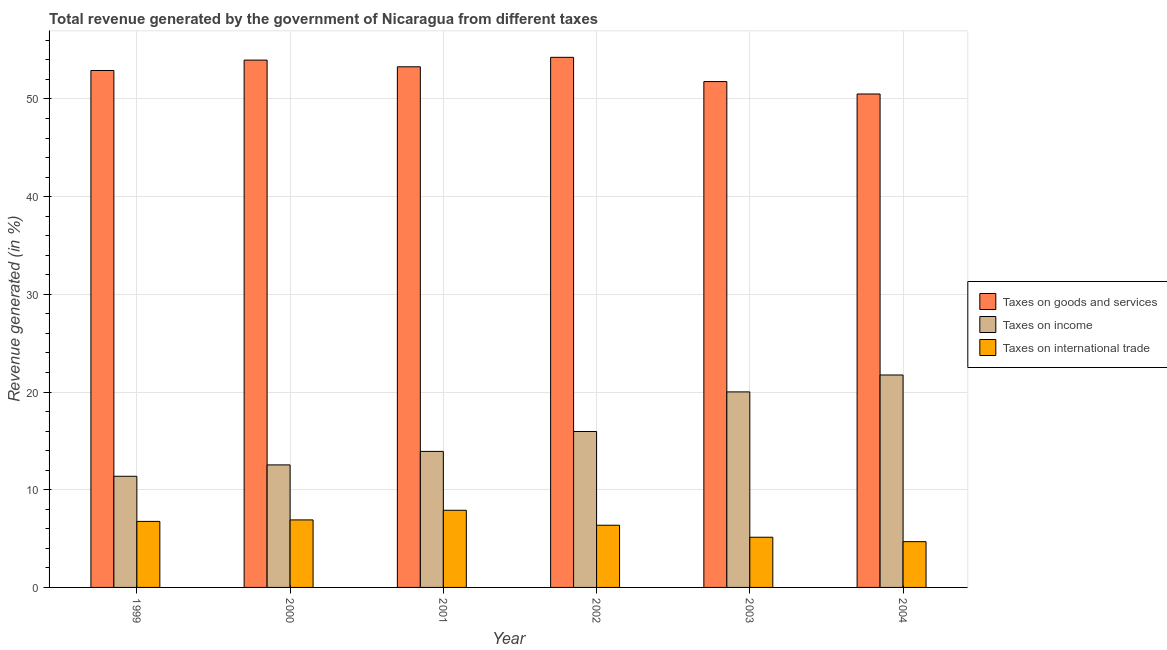How many different coloured bars are there?
Offer a terse response. 3. How many bars are there on the 5th tick from the right?
Make the answer very short. 3. What is the percentage of revenue generated by taxes on income in 2004?
Provide a short and direct response. 21.75. Across all years, what is the maximum percentage of revenue generated by taxes on income?
Give a very brief answer. 21.75. Across all years, what is the minimum percentage of revenue generated by taxes on income?
Offer a very short reply. 11.38. What is the total percentage of revenue generated by taxes on goods and services in the graph?
Ensure brevity in your answer.  316.75. What is the difference between the percentage of revenue generated by taxes on goods and services in 2000 and that in 2002?
Your response must be concise. -0.28. What is the difference between the percentage of revenue generated by taxes on goods and services in 1999 and the percentage of revenue generated by tax on international trade in 2000?
Keep it short and to the point. -1.06. What is the average percentage of revenue generated by tax on international trade per year?
Keep it short and to the point. 6.29. In how many years, is the percentage of revenue generated by taxes on goods and services greater than 16 %?
Keep it short and to the point. 6. What is the ratio of the percentage of revenue generated by taxes on goods and services in 1999 to that in 2002?
Your answer should be very brief. 0.98. What is the difference between the highest and the second highest percentage of revenue generated by taxes on goods and services?
Ensure brevity in your answer.  0.28. What is the difference between the highest and the lowest percentage of revenue generated by taxes on goods and services?
Offer a very short reply. 3.75. What does the 3rd bar from the left in 1999 represents?
Give a very brief answer. Taxes on international trade. What does the 1st bar from the right in 2001 represents?
Your answer should be compact. Taxes on international trade. How many bars are there?
Give a very brief answer. 18. How many years are there in the graph?
Give a very brief answer. 6. Are the values on the major ticks of Y-axis written in scientific E-notation?
Offer a very short reply. No. Where does the legend appear in the graph?
Provide a succinct answer. Center right. What is the title of the graph?
Provide a succinct answer. Total revenue generated by the government of Nicaragua from different taxes. Does "Financial account" appear as one of the legend labels in the graph?
Provide a succinct answer. No. What is the label or title of the X-axis?
Keep it short and to the point. Year. What is the label or title of the Y-axis?
Make the answer very short. Revenue generated (in %). What is the Revenue generated (in %) of Taxes on goods and services in 1999?
Your answer should be compact. 52.92. What is the Revenue generated (in %) of Taxes on income in 1999?
Offer a very short reply. 11.38. What is the Revenue generated (in %) in Taxes on international trade in 1999?
Keep it short and to the point. 6.76. What is the Revenue generated (in %) of Taxes on goods and services in 2000?
Ensure brevity in your answer.  53.98. What is the Revenue generated (in %) in Taxes on income in 2000?
Your answer should be compact. 12.54. What is the Revenue generated (in %) of Taxes on international trade in 2000?
Keep it short and to the point. 6.91. What is the Revenue generated (in %) in Taxes on goods and services in 2001?
Offer a terse response. 53.3. What is the Revenue generated (in %) of Taxes on income in 2001?
Keep it short and to the point. 13.93. What is the Revenue generated (in %) of Taxes on international trade in 2001?
Your answer should be very brief. 7.9. What is the Revenue generated (in %) of Taxes on goods and services in 2002?
Offer a very short reply. 54.26. What is the Revenue generated (in %) in Taxes on income in 2002?
Your answer should be very brief. 15.96. What is the Revenue generated (in %) in Taxes on international trade in 2002?
Provide a short and direct response. 6.36. What is the Revenue generated (in %) of Taxes on goods and services in 2003?
Give a very brief answer. 51.78. What is the Revenue generated (in %) in Taxes on income in 2003?
Give a very brief answer. 20.02. What is the Revenue generated (in %) in Taxes on international trade in 2003?
Your answer should be compact. 5.14. What is the Revenue generated (in %) of Taxes on goods and services in 2004?
Your answer should be compact. 50.51. What is the Revenue generated (in %) of Taxes on income in 2004?
Offer a terse response. 21.75. What is the Revenue generated (in %) in Taxes on international trade in 2004?
Keep it short and to the point. 4.69. Across all years, what is the maximum Revenue generated (in %) of Taxes on goods and services?
Give a very brief answer. 54.26. Across all years, what is the maximum Revenue generated (in %) in Taxes on income?
Offer a terse response. 21.75. Across all years, what is the maximum Revenue generated (in %) of Taxes on international trade?
Provide a succinct answer. 7.9. Across all years, what is the minimum Revenue generated (in %) of Taxes on goods and services?
Ensure brevity in your answer.  50.51. Across all years, what is the minimum Revenue generated (in %) in Taxes on income?
Give a very brief answer. 11.38. Across all years, what is the minimum Revenue generated (in %) of Taxes on international trade?
Ensure brevity in your answer.  4.69. What is the total Revenue generated (in %) in Taxes on goods and services in the graph?
Ensure brevity in your answer.  316.75. What is the total Revenue generated (in %) of Taxes on income in the graph?
Your answer should be very brief. 95.57. What is the total Revenue generated (in %) in Taxes on international trade in the graph?
Your response must be concise. 37.76. What is the difference between the Revenue generated (in %) of Taxes on goods and services in 1999 and that in 2000?
Provide a short and direct response. -1.06. What is the difference between the Revenue generated (in %) in Taxes on income in 1999 and that in 2000?
Your response must be concise. -1.16. What is the difference between the Revenue generated (in %) in Taxes on international trade in 1999 and that in 2000?
Your answer should be very brief. -0.15. What is the difference between the Revenue generated (in %) in Taxes on goods and services in 1999 and that in 2001?
Provide a succinct answer. -0.38. What is the difference between the Revenue generated (in %) of Taxes on income in 1999 and that in 2001?
Offer a terse response. -2.55. What is the difference between the Revenue generated (in %) in Taxes on international trade in 1999 and that in 2001?
Your answer should be very brief. -1.14. What is the difference between the Revenue generated (in %) of Taxes on goods and services in 1999 and that in 2002?
Keep it short and to the point. -1.35. What is the difference between the Revenue generated (in %) of Taxes on income in 1999 and that in 2002?
Give a very brief answer. -4.58. What is the difference between the Revenue generated (in %) in Taxes on international trade in 1999 and that in 2002?
Your answer should be compact. 0.39. What is the difference between the Revenue generated (in %) in Taxes on goods and services in 1999 and that in 2003?
Your answer should be compact. 1.13. What is the difference between the Revenue generated (in %) in Taxes on income in 1999 and that in 2003?
Offer a terse response. -8.64. What is the difference between the Revenue generated (in %) of Taxes on international trade in 1999 and that in 2003?
Keep it short and to the point. 1.62. What is the difference between the Revenue generated (in %) in Taxes on goods and services in 1999 and that in 2004?
Your answer should be very brief. 2.41. What is the difference between the Revenue generated (in %) of Taxes on income in 1999 and that in 2004?
Your answer should be compact. -10.37. What is the difference between the Revenue generated (in %) of Taxes on international trade in 1999 and that in 2004?
Keep it short and to the point. 2.07. What is the difference between the Revenue generated (in %) of Taxes on goods and services in 2000 and that in 2001?
Provide a succinct answer. 0.68. What is the difference between the Revenue generated (in %) in Taxes on income in 2000 and that in 2001?
Your answer should be compact. -1.38. What is the difference between the Revenue generated (in %) of Taxes on international trade in 2000 and that in 2001?
Ensure brevity in your answer.  -0.99. What is the difference between the Revenue generated (in %) in Taxes on goods and services in 2000 and that in 2002?
Offer a terse response. -0.28. What is the difference between the Revenue generated (in %) of Taxes on income in 2000 and that in 2002?
Your response must be concise. -3.42. What is the difference between the Revenue generated (in %) in Taxes on international trade in 2000 and that in 2002?
Your answer should be very brief. 0.55. What is the difference between the Revenue generated (in %) in Taxes on goods and services in 2000 and that in 2003?
Your answer should be compact. 2.2. What is the difference between the Revenue generated (in %) of Taxes on income in 2000 and that in 2003?
Ensure brevity in your answer.  -7.47. What is the difference between the Revenue generated (in %) in Taxes on international trade in 2000 and that in 2003?
Your response must be concise. 1.78. What is the difference between the Revenue generated (in %) in Taxes on goods and services in 2000 and that in 2004?
Give a very brief answer. 3.47. What is the difference between the Revenue generated (in %) in Taxes on income in 2000 and that in 2004?
Make the answer very short. -9.2. What is the difference between the Revenue generated (in %) in Taxes on international trade in 2000 and that in 2004?
Your answer should be very brief. 2.23. What is the difference between the Revenue generated (in %) of Taxes on goods and services in 2001 and that in 2002?
Your answer should be compact. -0.97. What is the difference between the Revenue generated (in %) in Taxes on income in 2001 and that in 2002?
Offer a very short reply. -2.04. What is the difference between the Revenue generated (in %) in Taxes on international trade in 2001 and that in 2002?
Your answer should be compact. 1.53. What is the difference between the Revenue generated (in %) in Taxes on goods and services in 2001 and that in 2003?
Your answer should be very brief. 1.51. What is the difference between the Revenue generated (in %) in Taxes on income in 2001 and that in 2003?
Provide a succinct answer. -6.09. What is the difference between the Revenue generated (in %) of Taxes on international trade in 2001 and that in 2003?
Make the answer very short. 2.76. What is the difference between the Revenue generated (in %) of Taxes on goods and services in 2001 and that in 2004?
Ensure brevity in your answer.  2.79. What is the difference between the Revenue generated (in %) of Taxes on income in 2001 and that in 2004?
Ensure brevity in your answer.  -7.82. What is the difference between the Revenue generated (in %) of Taxes on international trade in 2001 and that in 2004?
Ensure brevity in your answer.  3.21. What is the difference between the Revenue generated (in %) in Taxes on goods and services in 2002 and that in 2003?
Make the answer very short. 2.48. What is the difference between the Revenue generated (in %) of Taxes on income in 2002 and that in 2003?
Ensure brevity in your answer.  -4.05. What is the difference between the Revenue generated (in %) of Taxes on international trade in 2002 and that in 2003?
Give a very brief answer. 1.23. What is the difference between the Revenue generated (in %) of Taxes on goods and services in 2002 and that in 2004?
Give a very brief answer. 3.75. What is the difference between the Revenue generated (in %) in Taxes on income in 2002 and that in 2004?
Make the answer very short. -5.79. What is the difference between the Revenue generated (in %) in Taxes on international trade in 2002 and that in 2004?
Provide a short and direct response. 1.68. What is the difference between the Revenue generated (in %) of Taxes on goods and services in 2003 and that in 2004?
Provide a succinct answer. 1.27. What is the difference between the Revenue generated (in %) in Taxes on income in 2003 and that in 2004?
Your answer should be very brief. -1.73. What is the difference between the Revenue generated (in %) of Taxes on international trade in 2003 and that in 2004?
Provide a succinct answer. 0.45. What is the difference between the Revenue generated (in %) of Taxes on goods and services in 1999 and the Revenue generated (in %) of Taxes on income in 2000?
Provide a short and direct response. 40.37. What is the difference between the Revenue generated (in %) in Taxes on goods and services in 1999 and the Revenue generated (in %) in Taxes on international trade in 2000?
Your answer should be compact. 46.01. What is the difference between the Revenue generated (in %) in Taxes on income in 1999 and the Revenue generated (in %) in Taxes on international trade in 2000?
Make the answer very short. 4.47. What is the difference between the Revenue generated (in %) of Taxes on goods and services in 1999 and the Revenue generated (in %) of Taxes on income in 2001?
Keep it short and to the point. 38.99. What is the difference between the Revenue generated (in %) in Taxes on goods and services in 1999 and the Revenue generated (in %) in Taxes on international trade in 2001?
Your answer should be compact. 45.02. What is the difference between the Revenue generated (in %) of Taxes on income in 1999 and the Revenue generated (in %) of Taxes on international trade in 2001?
Keep it short and to the point. 3.48. What is the difference between the Revenue generated (in %) of Taxes on goods and services in 1999 and the Revenue generated (in %) of Taxes on income in 2002?
Offer a very short reply. 36.96. What is the difference between the Revenue generated (in %) in Taxes on goods and services in 1999 and the Revenue generated (in %) in Taxes on international trade in 2002?
Keep it short and to the point. 46.55. What is the difference between the Revenue generated (in %) of Taxes on income in 1999 and the Revenue generated (in %) of Taxes on international trade in 2002?
Your answer should be compact. 5.01. What is the difference between the Revenue generated (in %) of Taxes on goods and services in 1999 and the Revenue generated (in %) of Taxes on income in 2003?
Provide a succinct answer. 32.9. What is the difference between the Revenue generated (in %) of Taxes on goods and services in 1999 and the Revenue generated (in %) of Taxes on international trade in 2003?
Your response must be concise. 47.78. What is the difference between the Revenue generated (in %) of Taxes on income in 1999 and the Revenue generated (in %) of Taxes on international trade in 2003?
Offer a terse response. 6.24. What is the difference between the Revenue generated (in %) of Taxes on goods and services in 1999 and the Revenue generated (in %) of Taxes on income in 2004?
Your answer should be very brief. 31.17. What is the difference between the Revenue generated (in %) in Taxes on goods and services in 1999 and the Revenue generated (in %) in Taxes on international trade in 2004?
Offer a terse response. 48.23. What is the difference between the Revenue generated (in %) of Taxes on income in 1999 and the Revenue generated (in %) of Taxes on international trade in 2004?
Provide a short and direct response. 6.69. What is the difference between the Revenue generated (in %) of Taxes on goods and services in 2000 and the Revenue generated (in %) of Taxes on income in 2001?
Make the answer very short. 40.06. What is the difference between the Revenue generated (in %) in Taxes on goods and services in 2000 and the Revenue generated (in %) in Taxes on international trade in 2001?
Provide a succinct answer. 46.08. What is the difference between the Revenue generated (in %) in Taxes on income in 2000 and the Revenue generated (in %) in Taxes on international trade in 2001?
Give a very brief answer. 4.64. What is the difference between the Revenue generated (in %) of Taxes on goods and services in 2000 and the Revenue generated (in %) of Taxes on income in 2002?
Give a very brief answer. 38.02. What is the difference between the Revenue generated (in %) in Taxes on goods and services in 2000 and the Revenue generated (in %) in Taxes on international trade in 2002?
Give a very brief answer. 47.62. What is the difference between the Revenue generated (in %) of Taxes on income in 2000 and the Revenue generated (in %) of Taxes on international trade in 2002?
Offer a terse response. 6.18. What is the difference between the Revenue generated (in %) in Taxes on goods and services in 2000 and the Revenue generated (in %) in Taxes on income in 2003?
Offer a very short reply. 33.97. What is the difference between the Revenue generated (in %) in Taxes on goods and services in 2000 and the Revenue generated (in %) in Taxes on international trade in 2003?
Your answer should be very brief. 48.84. What is the difference between the Revenue generated (in %) of Taxes on income in 2000 and the Revenue generated (in %) of Taxes on international trade in 2003?
Offer a very short reply. 7.41. What is the difference between the Revenue generated (in %) in Taxes on goods and services in 2000 and the Revenue generated (in %) in Taxes on income in 2004?
Your answer should be compact. 32.23. What is the difference between the Revenue generated (in %) of Taxes on goods and services in 2000 and the Revenue generated (in %) of Taxes on international trade in 2004?
Make the answer very short. 49.29. What is the difference between the Revenue generated (in %) in Taxes on income in 2000 and the Revenue generated (in %) in Taxes on international trade in 2004?
Your answer should be very brief. 7.86. What is the difference between the Revenue generated (in %) in Taxes on goods and services in 2001 and the Revenue generated (in %) in Taxes on income in 2002?
Make the answer very short. 37.34. What is the difference between the Revenue generated (in %) of Taxes on goods and services in 2001 and the Revenue generated (in %) of Taxes on international trade in 2002?
Make the answer very short. 46.93. What is the difference between the Revenue generated (in %) in Taxes on income in 2001 and the Revenue generated (in %) in Taxes on international trade in 2002?
Offer a very short reply. 7.56. What is the difference between the Revenue generated (in %) of Taxes on goods and services in 2001 and the Revenue generated (in %) of Taxes on income in 2003?
Provide a succinct answer. 33.28. What is the difference between the Revenue generated (in %) of Taxes on goods and services in 2001 and the Revenue generated (in %) of Taxes on international trade in 2003?
Provide a short and direct response. 48.16. What is the difference between the Revenue generated (in %) of Taxes on income in 2001 and the Revenue generated (in %) of Taxes on international trade in 2003?
Provide a short and direct response. 8.79. What is the difference between the Revenue generated (in %) in Taxes on goods and services in 2001 and the Revenue generated (in %) in Taxes on income in 2004?
Offer a terse response. 31.55. What is the difference between the Revenue generated (in %) in Taxes on goods and services in 2001 and the Revenue generated (in %) in Taxes on international trade in 2004?
Make the answer very short. 48.61. What is the difference between the Revenue generated (in %) in Taxes on income in 2001 and the Revenue generated (in %) in Taxes on international trade in 2004?
Your response must be concise. 9.24. What is the difference between the Revenue generated (in %) in Taxes on goods and services in 2002 and the Revenue generated (in %) in Taxes on income in 2003?
Offer a terse response. 34.25. What is the difference between the Revenue generated (in %) in Taxes on goods and services in 2002 and the Revenue generated (in %) in Taxes on international trade in 2003?
Offer a very short reply. 49.13. What is the difference between the Revenue generated (in %) in Taxes on income in 2002 and the Revenue generated (in %) in Taxes on international trade in 2003?
Give a very brief answer. 10.83. What is the difference between the Revenue generated (in %) in Taxes on goods and services in 2002 and the Revenue generated (in %) in Taxes on income in 2004?
Provide a succinct answer. 32.52. What is the difference between the Revenue generated (in %) of Taxes on goods and services in 2002 and the Revenue generated (in %) of Taxes on international trade in 2004?
Offer a very short reply. 49.58. What is the difference between the Revenue generated (in %) in Taxes on income in 2002 and the Revenue generated (in %) in Taxes on international trade in 2004?
Give a very brief answer. 11.28. What is the difference between the Revenue generated (in %) of Taxes on goods and services in 2003 and the Revenue generated (in %) of Taxes on income in 2004?
Offer a terse response. 30.04. What is the difference between the Revenue generated (in %) of Taxes on goods and services in 2003 and the Revenue generated (in %) of Taxes on international trade in 2004?
Provide a succinct answer. 47.1. What is the difference between the Revenue generated (in %) in Taxes on income in 2003 and the Revenue generated (in %) in Taxes on international trade in 2004?
Your answer should be very brief. 15.33. What is the average Revenue generated (in %) in Taxes on goods and services per year?
Give a very brief answer. 52.79. What is the average Revenue generated (in %) of Taxes on income per year?
Offer a very short reply. 15.93. What is the average Revenue generated (in %) in Taxes on international trade per year?
Make the answer very short. 6.29. In the year 1999, what is the difference between the Revenue generated (in %) of Taxes on goods and services and Revenue generated (in %) of Taxes on income?
Your answer should be compact. 41.54. In the year 1999, what is the difference between the Revenue generated (in %) of Taxes on goods and services and Revenue generated (in %) of Taxes on international trade?
Give a very brief answer. 46.16. In the year 1999, what is the difference between the Revenue generated (in %) in Taxes on income and Revenue generated (in %) in Taxes on international trade?
Provide a succinct answer. 4.62. In the year 2000, what is the difference between the Revenue generated (in %) in Taxes on goods and services and Revenue generated (in %) in Taxes on income?
Offer a terse response. 41.44. In the year 2000, what is the difference between the Revenue generated (in %) of Taxes on goods and services and Revenue generated (in %) of Taxes on international trade?
Keep it short and to the point. 47.07. In the year 2000, what is the difference between the Revenue generated (in %) of Taxes on income and Revenue generated (in %) of Taxes on international trade?
Keep it short and to the point. 5.63. In the year 2001, what is the difference between the Revenue generated (in %) of Taxes on goods and services and Revenue generated (in %) of Taxes on income?
Ensure brevity in your answer.  39.37. In the year 2001, what is the difference between the Revenue generated (in %) of Taxes on goods and services and Revenue generated (in %) of Taxes on international trade?
Ensure brevity in your answer.  45.4. In the year 2001, what is the difference between the Revenue generated (in %) of Taxes on income and Revenue generated (in %) of Taxes on international trade?
Offer a terse response. 6.03. In the year 2002, what is the difference between the Revenue generated (in %) of Taxes on goods and services and Revenue generated (in %) of Taxes on income?
Your answer should be compact. 38.3. In the year 2002, what is the difference between the Revenue generated (in %) of Taxes on goods and services and Revenue generated (in %) of Taxes on international trade?
Offer a terse response. 47.9. In the year 2002, what is the difference between the Revenue generated (in %) in Taxes on income and Revenue generated (in %) in Taxes on international trade?
Provide a succinct answer. 9.6. In the year 2003, what is the difference between the Revenue generated (in %) in Taxes on goods and services and Revenue generated (in %) in Taxes on income?
Your answer should be compact. 31.77. In the year 2003, what is the difference between the Revenue generated (in %) of Taxes on goods and services and Revenue generated (in %) of Taxes on international trade?
Your response must be concise. 46.65. In the year 2003, what is the difference between the Revenue generated (in %) in Taxes on income and Revenue generated (in %) in Taxes on international trade?
Your response must be concise. 14.88. In the year 2004, what is the difference between the Revenue generated (in %) in Taxes on goods and services and Revenue generated (in %) in Taxes on income?
Your answer should be very brief. 28.76. In the year 2004, what is the difference between the Revenue generated (in %) of Taxes on goods and services and Revenue generated (in %) of Taxes on international trade?
Provide a short and direct response. 45.82. In the year 2004, what is the difference between the Revenue generated (in %) in Taxes on income and Revenue generated (in %) in Taxes on international trade?
Your response must be concise. 17.06. What is the ratio of the Revenue generated (in %) of Taxes on goods and services in 1999 to that in 2000?
Give a very brief answer. 0.98. What is the ratio of the Revenue generated (in %) of Taxes on income in 1999 to that in 2000?
Your response must be concise. 0.91. What is the ratio of the Revenue generated (in %) of Taxes on international trade in 1999 to that in 2000?
Your answer should be very brief. 0.98. What is the ratio of the Revenue generated (in %) of Taxes on goods and services in 1999 to that in 2001?
Ensure brevity in your answer.  0.99. What is the ratio of the Revenue generated (in %) in Taxes on income in 1999 to that in 2001?
Your answer should be compact. 0.82. What is the ratio of the Revenue generated (in %) in Taxes on international trade in 1999 to that in 2001?
Give a very brief answer. 0.86. What is the ratio of the Revenue generated (in %) of Taxes on goods and services in 1999 to that in 2002?
Your answer should be compact. 0.98. What is the ratio of the Revenue generated (in %) of Taxes on income in 1999 to that in 2002?
Provide a short and direct response. 0.71. What is the ratio of the Revenue generated (in %) in Taxes on international trade in 1999 to that in 2002?
Give a very brief answer. 1.06. What is the ratio of the Revenue generated (in %) in Taxes on goods and services in 1999 to that in 2003?
Provide a succinct answer. 1.02. What is the ratio of the Revenue generated (in %) of Taxes on income in 1999 to that in 2003?
Your answer should be compact. 0.57. What is the ratio of the Revenue generated (in %) of Taxes on international trade in 1999 to that in 2003?
Keep it short and to the point. 1.32. What is the ratio of the Revenue generated (in %) of Taxes on goods and services in 1999 to that in 2004?
Offer a terse response. 1.05. What is the ratio of the Revenue generated (in %) of Taxes on income in 1999 to that in 2004?
Your answer should be compact. 0.52. What is the ratio of the Revenue generated (in %) in Taxes on international trade in 1999 to that in 2004?
Provide a succinct answer. 1.44. What is the ratio of the Revenue generated (in %) of Taxes on goods and services in 2000 to that in 2001?
Your answer should be very brief. 1.01. What is the ratio of the Revenue generated (in %) of Taxes on income in 2000 to that in 2001?
Make the answer very short. 0.9. What is the ratio of the Revenue generated (in %) of Taxes on international trade in 2000 to that in 2001?
Keep it short and to the point. 0.88. What is the ratio of the Revenue generated (in %) in Taxes on goods and services in 2000 to that in 2002?
Your response must be concise. 0.99. What is the ratio of the Revenue generated (in %) in Taxes on income in 2000 to that in 2002?
Make the answer very short. 0.79. What is the ratio of the Revenue generated (in %) in Taxes on international trade in 2000 to that in 2002?
Keep it short and to the point. 1.09. What is the ratio of the Revenue generated (in %) of Taxes on goods and services in 2000 to that in 2003?
Make the answer very short. 1.04. What is the ratio of the Revenue generated (in %) in Taxes on income in 2000 to that in 2003?
Give a very brief answer. 0.63. What is the ratio of the Revenue generated (in %) in Taxes on international trade in 2000 to that in 2003?
Keep it short and to the point. 1.35. What is the ratio of the Revenue generated (in %) of Taxes on goods and services in 2000 to that in 2004?
Keep it short and to the point. 1.07. What is the ratio of the Revenue generated (in %) in Taxes on income in 2000 to that in 2004?
Your answer should be very brief. 0.58. What is the ratio of the Revenue generated (in %) of Taxes on international trade in 2000 to that in 2004?
Keep it short and to the point. 1.47. What is the ratio of the Revenue generated (in %) in Taxes on goods and services in 2001 to that in 2002?
Offer a very short reply. 0.98. What is the ratio of the Revenue generated (in %) of Taxes on income in 2001 to that in 2002?
Offer a very short reply. 0.87. What is the ratio of the Revenue generated (in %) of Taxes on international trade in 2001 to that in 2002?
Offer a very short reply. 1.24. What is the ratio of the Revenue generated (in %) of Taxes on goods and services in 2001 to that in 2003?
Provide a short and direct response. 1.03. What is the ratio of the Revenue generated (in %) of Taxes on income in 2001 to that in 2003?
Provide a short and direct response. 0.7. What is the ratio of the Revenue generated (in %) of Taxes on international trade in 2001 to that in 2003?
Provide a short and direct response. 1.54. What is the ratio of the Revenue generated (in %) in Taxes on goods and services in 2001 to that in 2004?
Your response must be concise. 1.06. What is the ratio of the Revenue generated (in %) in Taxes on income in 2001 to that in 2004?
Offer a very short reply. 0.64. What is the ratio of the Revenue generated (in %) of Taxes on international trade in 2001 to that in 2004?
Make the answer very short. 1.69. What is the ratio of the Revenue generated (in %) of Taxes on goods and services in 2002 to that in 2003?
Your response must be concise. 1.05. What is the ratio of the Revenue generated (in %) in Taxes on income in 2002 to that in 2003?
Offer a terse response. 0.8. What is the ratio of the Revenue generated (in %) of Taxes on international trade in 2002 to that in 2003?
Your answer should be compact. 1.24. What is the ratio of the Revenue generated (in %) in Taxes on goods and services in 2002 to that in 2004?
Provide a succinct answer. 1.07. What is the ratio of the Revenue generated (in %) of Taxes on income in 2002 to that in 2004?
Your answer should be compact. 0.73. What is the ratio of the Revenue generated (in %) in Taxes on international trade in 2002 to that in 2004?
Offer a very short reply. 1.36. What is the ratio of the Revenue generated (in %) of Taxes on goods and services in 2003 to that in 2004?
Provide a short and direct response. 1.03. What is the ratio of the Revenue generated (in %) of Taxes on income in 2003 to that in 2004?
Keep it short and to the point. 0.92. What is the ratio of the Revenue generated (in %) of Taxes on international trade in 2003 to that in 2004?
Keep it short and to the point. 1.1. What is the difference between the highest and the second highest Revenue generated (in %) of Taxes on goods and services?
Provide a short and direct response. 0.28. What is the difference between the highest and the second highest Revenue generated (in %) in Taxes on income?
Give a very brief answer. 1.73. What is the difference between the highest and the lowest Revenue generated (in %) in Taxes on goods and services?
Provide a short and direct response. 3.75. What is the difference between the highest and the lowest Revenue generated (in %) in Taxes on income?
Make the answer very short. 10.37. What is the difference between the highest and the lowest Revenue generated (in %) of Taxes on international trade?
Offer a very short reply. 3.21. 